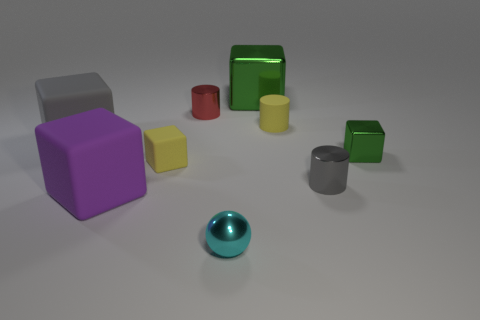Which object stands out the most to you? The shiny teal sphere stands out due to its distinct, reflective surface and spherical shape which contrasts with the matte textures and angular shapes of the other objects. 